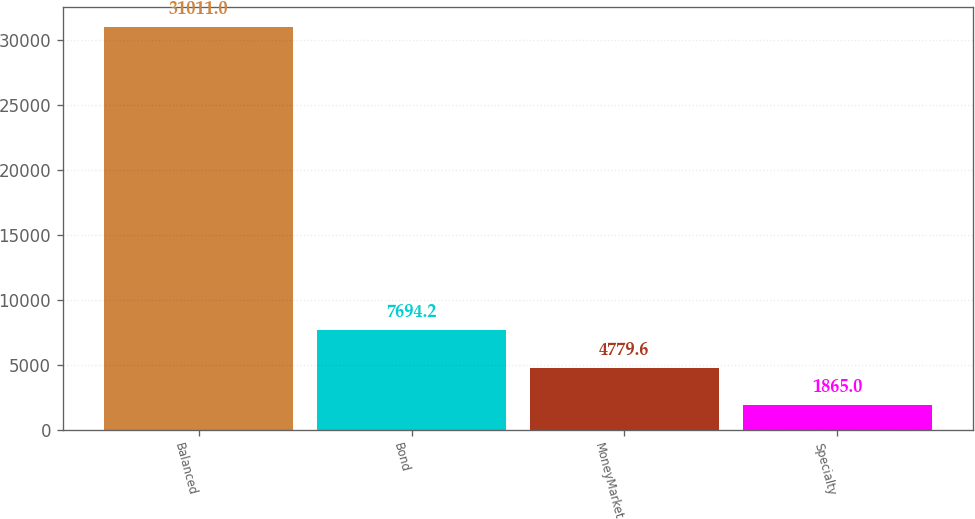Convert chart. <chart><loc_0><loc_0><loc_500><loc_500><bar_chart><fcel>Balanced<fcel>Bond<fcel>MoneyMarket<fcel>Specialty<nl><fcel>31011<fcel>7694.2<fcel>4779.6<fcel>1865<nl></chart> 